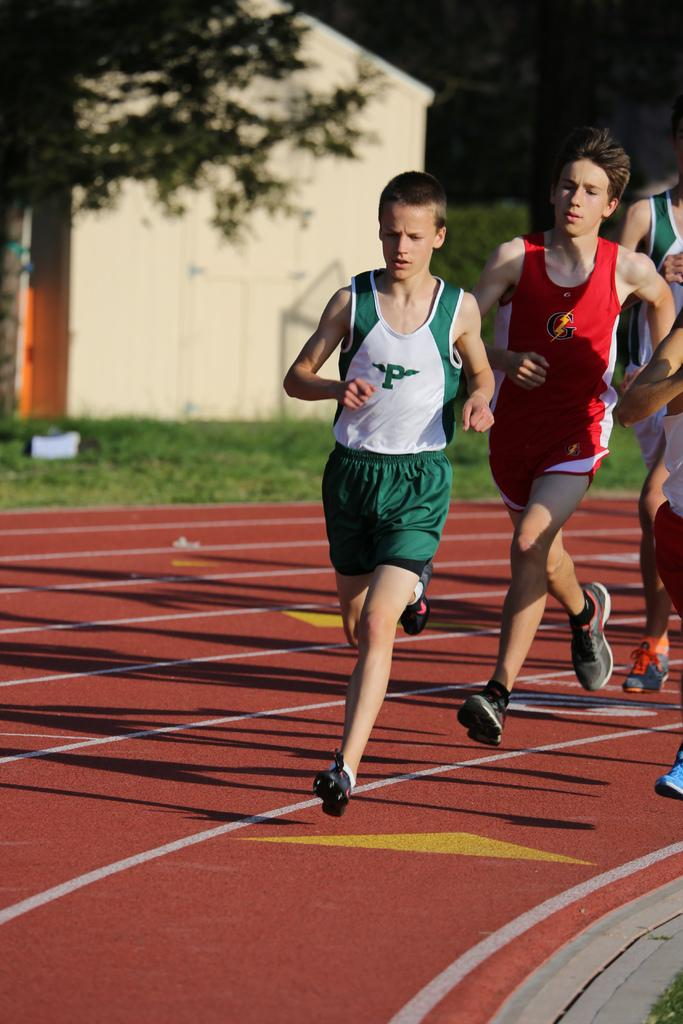What activity is taking place in the image? There is a running race in the image. Who is participating in the race? Boys are participating in the race. On what surface is the race taking place? The race is taking place on the ground. What type of vegetation is visible behind the ground? There is grass and trees behind the ground. What type of ship can be seen sailing in the background of the image? There is no ship present in the image; it features a running race with boys on the ground. Can you tell me the name of the secretary who is organizing the race in the image? There is no secretary mentioned or depicted in the image; it focuses on the boys participating in the race. 